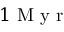Convert formula to latex. <formula><loc_0><loc_0><loc_500><loc_500>1 M y r</formula> 